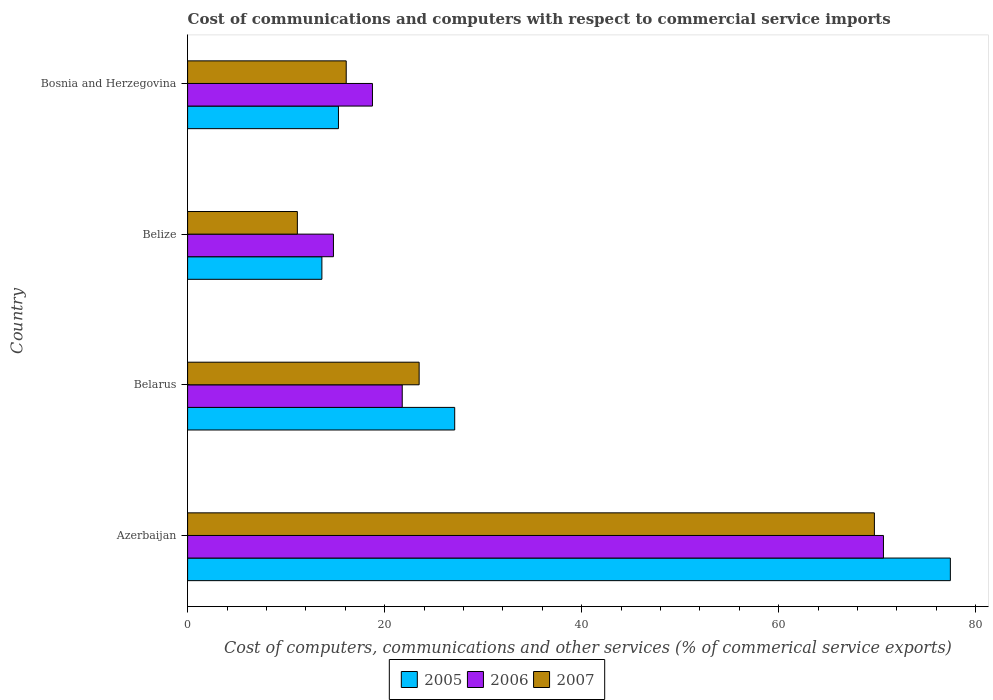How many groups of bars are there?
Provide a short and direct response. 4. Are the number of bars per tick equal to the number of legend labels?
Offer a terse response. Yes. Are the number of bars on each tick of the Y-axis equal?
Provide a short and direct response. Yes. What is the label of the 2nd group of bars from the top?
Offer a very short reply. Belize. What is the cost of communications and computers in 2007 in Belize?
Give a very brief answer. 11.14. Across all countries, what is the maximum cost of communications and computers in 2005?
Keep it short and to the point. 77.43. Across all countries, what is the minimum cost of communications and computers in 2006?
Provide a short and direct response. 14.8. In which country was the cost of communications and computers in 2005 maximum?
Your response must be concise. Azerbaijan. In which country was the cost of communications and computers in 2006 minimum?
Keep it short and to the point. Belize. What is the total cost of communications and computers in 2005 in the graph?
Keep it short and to the point. 133.49. What is the difference between the cost of communications and computers in 2007 in Azerbaijan and that in Belize?
Provide a succinct answer. 58.57. What is the difference between the cost of communications and computers in 2007 in Belize and the cost of communications and computers in 2006 in Belarus?
Your answer should be compact. -10.65. What is the average cost of communications and computers in 2006 per country?
Ensure brevity in your answer.  31.5. What is the difference between the cost of communications and computers in 2006 and cost of communications and computers in 2007 in Belarus?
Make the answer very short. -1.72. What is the ratio of the cost of communications and computers in 2006 in Azerbaijan to that in Bosnia and Herzegovina?
Your response must be concise. 3.76. What is the difference between the highest and the second highest cost of communications and computers in 2007?
Offer a very short reply. 46.21. What is the difference between the highest and the lowest cost of communications and computers in 2005?
Provide a succinct answer. 63.8. Is the sum of the cost of communications and computers in 2007 in Azerbaijan and Belize greater than the maximum cost of communications and computers in 2005 across all countries?
Your answer should be compact. Yes. What does the 1st bar from the top in Belarus represents?
Make the answer very short. 2007. How many countries are there in the graph?
Your response must be concise. 4. What is the difference between two consecutive major ticks on the X-axis?
Your answer should be compact. 20. Does the graph contain grids?
Ensure brevity in your answer.  No. What is the title of the graph?
Offer a very short reply. Cost of communications and computers with respect to commercial service imports. What is the label or title of the X-axis?
Provide a succinct answer. Cost of computers, communications and other services (% of commerical service exports). What is the Cost of computers, communications and other services (% of commerical service exports) of 2005 in Azerbaijan?
Your answer should be very brief. 77.43. What is the Cost of computers, communications and other services (% of commerical service exports) in 2006 in Azerbaijan?
Give a very brief answer. 70.64. What is the Cost of computers, communications and other services (% of commerical service exports) in 2007 in Azerbaijan?
Your answer should be very brief. 69.72. What is the Cost of computers, communications and other services (% of commerical service exports) in 2005 in Belarus?
Your answer should be very brief. 27.11. What is the Cost of computers, communications and other services (% of commerical service exports) of 2006 in Belarus?
Your response must be concise. 21.79. What is the Cost of computers, communications and other services (% of commerical service exports) of 2007 in Belarus?
Keep it short and to the point. 23.5. What is the Cost of computers, communications and other services (% of commerical service exports) in 2005 in Belize?
Provide a short and direct response. 13.63. What is the Cost of computers, communications and other services (% of commerical service exports) in 2006 in Belize?
Provide a succinct answer. 14.8. What is the Cost of computers, communications and other services (% of commerical service exports) of 2007 in Belize?
Offer a very short reply. 11.14. What is the Cost of computers, communications and other services (% of commerical service exports) in 2005 in Bosnia and Herzegovina?
Your answer should be very brief. 15.31. What is the Cost of computers, communications and other services (% of commerical service exports) in 2006 in Bosnia and Herzegovina?
Ensure brevity in your answer.  18.76. What is the Cost of computers, communications and other services (% of commerical service exports) of 2007 in Bosnia and Herzegovina?
Make the answer very short. 16.1. Across all countries, what is the maximum Cost of computers, communications and other services (% of commerical service exports) of 2005?
Provide a succinct answer. 77.43. Across all countries, what is the maximum Cost of computers, communications and other services (% of commerical service exports) in 2006?
Keep it short and to the point. 70.64. Across all countries, what is the maximum Cost of computers, communications and other services (% of commerical service exports) in 2007?
Your response must be concise. 69.72. Across all countries, what is the minimum Cost of computers, communications and other services (% of commerical service exports) of 2005?
Your response must be concise. 13.63. Across all countries, what is the minimum Cost of computers, communications and other services (% of commerical service exports) in 2006?
Give a very brief answer. 14.8. Across all countries, what is the minimum Cost of computers, communications and other services (% of commerical service exports) in 2007?
Offer a very short reply. 11.14. What is the total Cost of computers, communications and other services (% of commerical service exports) of 2005 in the graph?
Keep it short and to the point. 133.49. What is the total Cost of computers, communications and other services (% of commerical service exports) in 2006 in the graph?
Offer a terse response. 125.99. What is the total Cost of computers, communications and other services (% of commerical service exports) in 2007 in the graph?
Keep it short and to the point. 120.46. What is the difference between the Cost of computers, communications and other services (% of commerical service exports) in 2005 in Azerbaijan and that in Belarus?
Ensure brevity in your answer.  50.31. What is the difference between the Cost of computers, communications and other services (% of commerical service exports) of 2006 in Azerbaijan and that in Belarus?
Your response must be concise. 48.85. What is the difference between the Cost of computers, communications and other services (% of commerical service exports) of 2007 in Azerbaijan and that in Belarus?
Make the answer very short. 46.21. What is the difference between the Cost of computers, communications and other services (% of commerical service exports) in 2005 in Azerbaijan and that in Belize?
Offer a very short reply. 63.8. What is the difference between the Cost of computers, communications and other services (% of commerical service exports) of 2006 in Azerbaijan and that in Belize?
Offer a very short reply. 55.83. What is the difference between the Cost of computers, communications and other services (% of commerical service exports) in 2007 in Azerbaijan and that in Belize?
Offer a very short reply. 58.57. What is the difference between the Cost of computers, communications and other services (% of commerical service exports) of 2005 in Azerbaijan and that in Bosnia and Herzegovina?
Your answer should be very brief. 62.11. What is the difference between the Cost of computers, communications and other services (% of commerical service exports) of 2006 in Azerbaijan and that in Bosnia and Herzegovina?
Your response must be concise. 51.87. What is the difference between the Cost of computers, communications and other services (% of commerical service exports) in 2007 in Azerbaijan and that in Bosnia and Herzegovina?
Make the answer very short. 53.61. What is the difference between the Cost of computers, communications and other services (% of commerical service exports) of 2005 in Belarus and that in Belize?
Your response must be concise. 13.48. What is the difference between the Cost of computers, communications and other services (% of commerical service exports) in 2006 in Belarus and that in Belize?
Keep it short and to the point. 6.98. What is the difference between the Cost of computers, communications and other services (% of commerical service exports) of 2007 in Belarus and that in Belize?
Offer a terse response. 12.36. What is the difference between the Cost of computers, communications and other services (% of commerical service exports) of 2005 in Belarus and that in Bosnia and Herzegovina?
Your answer should be very brief. 11.8. What is the difference between the Cost of computers, communications and other services (% of commerical service exports) of 2006 in Belarus and that in Bosnia and Herzegovina?
Provide a short and direct response. 3.02. What is the difference between the Cost of computers, communications and other services (% of commerical service exports) of 2007 in Belarus and that in Bosnia and Herzegovina?
Ensure brevity in your answer.  7.4. What is the difference between the Cost of computers, communications and other services (% of commerical service exports) of 2005 in Belize and that in Bosnia and Herzegovina?
Your answer should be compact. -1.68. What is the difference between the Cost of computers, communications and other services (% of commerical service exports) of 2006 in Belize and that in Bosnia and Herzegovina?
Your response must be concise. -3.96. What is the difference between the Cost of computers, communications and other services (% of commerical service exports) of 2007 in Belize and that in Bosnia and Herzegovina?
Offer a very short reply. -4.96. What is the difference between the Cost of computers, communications and other services (% of commerical service exports) of 2005 in Azerbaijan and the Cost of computers, communications and other services (% of commerical service exports) of 2006 in Belarus?
Your answer should be very brief. 55.64. What is the difference between the Cost of computers, communications and other services (% of commerical service exports) of 2005 in Azerbaijan and the Cost of computers, communications and other services (% of commerical service exports) of 2007 in Belarus?
Your answer should be compact. 53.92. What is the difference between the Cost of computers, communications and other services (% of commerical service exports) of 2006 in Azerbaijan and the Cost of computers, communications and other services (% of commerical service exports) of 2007 in Belarus?
Provide a short and direct response. 47.13. What is the difference between the Cost of computers, communications and other services (% of commerical service exports) in 2005 in Azerbaijan and the Cost of computers, communications and other services (% of commerical service exports) in 2006 in Belize?
Provide a succinct answer. 62.62. What is the difference between the Cost of computers, communications and other services (% of commerical service exports) in 2005 in Azerbaijan and the Cost of computers, communications and other services (% of commerical service exports) in 2007 in Belize?
Offer a very short reply. 66.29. What is the difference between the Cost of computers, communications and other services (% of commerical service exports) of 2006 in Azerbaijan and the Cost of computers, communications and other services (% of commerical service exports) of 2007 in Belize?
Your response must be concise. 59.49. What is the difference between the Cost of computers, communications and other services (% of commerical service exports) in 2005 in Azerbaijan and the Cost of computers, communications and other services (% of commerical service exports) in 2006 in Bosnia and Herzegovina?
Make the answer very short. 58.66. What is the difference between the Cost of computers, communications and other services (% of commerical service exports) of 2005 in Azerbaijan and the Cost of computers, communications and other services (% of commerical service exports) of 2007 in Bosnia and Herzegovina?
Your response must be concise. 61.33. What is the difference between the Cost of computers, communications and other services (% of commerical service exports) of 2006 in Azerbaijan and the Cost of computers, communications and other services (% of commerical service exports) of 2007 in Bosnia and Herzegovina?
Offer a very short reply. 54.53. What is the difference between the Cost of computers, communications and other services (% of commerical service exports) in 2005 in Belarus and the Cost of computers, communications and other services (% of commerical service exports) in 2006 in Belize?
Provide a short and direct response. 12.31. What is the difference between the Cost of computers, communications and other services (% of commerical service exports) in 2005 in Belarus and the Cost of computers, communications and other services (% of commerical service exports) in 2007 in Belize?
Ensure brevity in your answer.  15.97. What is the difference between the Cost of computers, communications and other services (% of commerical service exports) in 2006 in Belarus and the Cost of computers, communications and other services (% of commerical service exports) in 2007 in Belize?
Your response must be concise. 10.65. What is the difference between the Cost of computers, communications and other services (% of commerical service exports) of 2005 in Belarus and the Cost of computers, communications and other services (% of commerical service exports) of 2006 in Bosnia and Herzegovina?
Your answer should be very brief. 8.35. What is the difference between the Cost of computers, communications and other services (% of commerical service exports) of 2005 in Belarus and the Cost of computers, communications and other services (% of commerical service exports) of 2007 in Bosnia and Herzegovina?
Provide a succinct answer. 11.01. What is the difference between the Cost of computers, communications and other services (% of commerical service exports) of 2006 in Belarus and the Cost of computers, communications and other services (% of commerical service exports) of 2007 in Bosnia and Herzegovina?
Your response must be concise. 5.69. What is the difference between the Cost of computers, communications and other services (% of commerical service exports) of 2005 in Belize and the Cost of computers, communications and other services (% of commerical service exports) of 2006 in Bosnia and Herzegovina?
Ensure brevity in your answer.  -5.13. What is the difference between the Cost of computers, communications and other services (% of commerical service exports) in 2005 in Belize and the Cost of computers, communications and other services (% of commerical service exports) in 2007 in Bosnia and Herzegovina?
Provide a succinct answer. -2.47. What is the difference between the Cost of computers, communications and other services (% of commerical service exports) in 2006 in Belize and the Cost of computers, communications and other services (% of commerical service exports) in 2007 in Bosnia and Herzegovina?
Make the answer very short. -1.3. What is the average Cost of computers, communications and other services (% of commerical service exports) of 2005 per country?
Provide a short and direct response. 33.37. What is the average Cost of computers, communications and other services (% of commerical service exports) in 2006 per country?
Your answer should be very brief. 31.5. What is the average Cost of computers, communications and other services (% of commerical service exports) in 2007 per country?
Provide a succinct answer. 30.12. What is the difference between the Cost of computers, communications and other services (% of commerical service exports) of 2005 and Cost of computers, communications and other services (% of commerical service exports) of 2006 in Azerbaijan?
Ensure brevity in your answer.  6.79. What is the difference between the Cost of computers, communications and other services (% of commerical service exports) of 2005 and Cost of computers, communications and other services (% of commerical service exports) of 2007 in Azerbaijan?
Your answer should be very brief. 7.71. What is the difference between the Cost of computers, communications and other services (% of commerical service exports) in 2006 and Cost of computers, communications and other services (% of commerical service exports) in 2007 in Azerbaijan?
Offer a very short reply. 0.92. What is the difference between the Cost of computers, communications and other services (% of commerical service exports) of 2005 and Cost of computers, communications and other services (% of commerical service exports) of 2006 in Belarus?
Keep it short and to the point. 5.33. What is the difference between the Cost of computers, communications and other services (% of commerical service exports) of 2005 and Cost of computers, communications and other services (% of commerical service exports) of 2007 in Belarus?
Provide a short and direct response. 3.61. What is the difference between the Cost of computers, communications and other services (% of commerical service exports) in 2006 and Cost of computers, communications and other services (% of commerical service exports) in 2007 in Belarus?
Provide a succinct answer. -1.72. What is the difference between the Cost of computers, communications and other services (% of commerical service exports) of 2005 and Cost of computers, communications and other services (% of commerical service exports) of 2006 in Belize?
Give a very brief answer. -1.17. What is the difference between the Cost of computers, communications and other services (% of commerical service exports) of 2005 and Cost of computers, communications and other services (% of commerical service exports) of 2007 in Belize?
Your answer should be compact. 2.49. What is the difference between the Cost of computers, communications and other services (% of commerical service exports) in 2006 and Cost of computers, communications and other services (% of commerical service exports) in 2007 in Belize?
Provide a short and direct response. 3.66. What is the difference between the Cost of computers, communications and other services (% of commerical service exports) in 2005 and Cost of computers, communications and other services (% of commerical service exports) in 2006 in Bosnia and Herzegovina?
Your answer should be very brief. -3.45. What is the difference between the Cost of computers, communications and other services (% of commerical service exports) of 2005 and Cost of computers, communications and other services (% of commerical service exports) of 2007 in Bosnia and Herzegovina?
Make the answer very short. -0.79. What is the difference between the Cost of computers, communications and other services (% of commerical service exports) in 2006 and Cost of computers, communications and other services (% of commerical service exports) in 2007 in Bosnia and Herzegovina?
Offer a terse response. 2.66. What is the ratio of the Cost of computers, communications and other services (% of commerical service exports) in 2005 in Azerbaijan to that in Belarus?
Provide a short and direct response. 2.86. What is the ratio of the Cost of computers, communications and other services (% of commerical service exports) in 2006 in Azerbaijan to that in Belarus?
Your response must be concise. 3.24. What is the ratio of the Cost of computers, communications and other services (% of commerical service exports) in 2007 in Azerbaijan to that in Belarus?
Provide a succinct answer. 2.97. What is the ratio of the Cost of computers, communications and other services (% of commerical service exports) of 2005 in Azerbaijan to that in Belize?
Provide a short and direct response. 5.68. What is the ratio of the Cost of computers, communications and other services (% of commerical service exports) in 2006 in Azerbaijan to that in Belize?
Your answer should be very brief. 4.77. What is the ratio of the Cost of computers, communications and other services (% of commerical service exports) in 2007 in Azerbaijan to that in Belize?
Offer a terse response. 6.26. What is the ratio of the Cost of computers, communications and other services (% of commerical service exports) in 2005 in Azerbaijan to that in Bosnia and Herzegovina?
Provide a short and direct response. 5.06. What is the ratio of the Cost of computers, communications and other services (% of commerical service exports) in 2006 in Azerbaijan to that in Bosnia and Herzegovina?
Your answer should be very brief. 3.76. What is the ratio of the Cost of computers, communications and other services (% of commerical service exports) in 2007 in Azerbaijan to that in Bosnia and Herzegovina?
Your response must be concise. 4.33. What is the ratio of the Cost of computers, communications and other services (% of commerical service exports) in 2005 in Belarus to that in Belize?
Provide a succinct answer. 1.99. What is the ratio of the Cost of computers, communications and other services (% of commerical service exports) of 2006 in Belarus to that in Belize?
Give a very brief answer. 1.47. What is the ratio of the Cost of computers, communications and other services (% of commerical service exports) of 2007 in Belarus to that in Belize?
Offer a terse response. 2.11. What is the ratio of the Cost of computers, communications and other services (% of commerical service exports) in 2005 in Belarus to that in Bosnia and Herzegovina?
Your answer should be very brief. 1.77. What is the ratio of the Cost of computers, communications and other services (% of commerical service exports) in 2006 in Belarus to that in Bosnia and Herzegovina?
Make the answer very short. 1.16. What is the ratio of the Cost of computers, communications and other services (% of commerical service exports) of 2007 in Belarus to that in Bosnia and Herzegovina?
Your response must be concise. 1.46. What is the ratio of the Cost of computers, communications and other services (% of commerical service exports) in 2005 in Belize to that in Bosnia and Herzegovina?
Ensure brevity in your answer.  0.89. What is the ratio of the Cost of computers, communications and other services (% of commerical service exports) of 2006 in Belize to that in Bosnia and Herzegovina?
Provide a short and direct response. 0.79. What is the ratio of the Cost of computers, communications and other services (% of commerical service exports) in 2007 in Belize to that in Bosnia and Herzegovina?
Your answer should be compact. 0.69. What is the difference between the highest and the second highest Cost of computers, communications and other services (% of commerical service exports) in 2005?
Provide a succinct answer. 50.31. What is the difference between the highest and the second highest Cost of computers, communications and other services (% of commerical service exports) of 2006?
Your response must be concise. 48.85. What is the difference between the highest and the second highest Cost of computers, communications and other services (% of commerical service exports) in 2007?
Provide a succinct answer. 46.21. What is the difference between the highest and the lowest Cost of computers, communications and other services (% of commerical service exports) of 2005?
Your answer should be very brief. 63.8. What is the difference between the highest and the lowest Cost of computers, communications and other services (% of commerical service exports) in 2006?
Provide a succinct answer. 55.83. What is the difference between the highest and the lowest Cost of computers, communications and other services (% of commerical service exports) in 2007?
Provide a succinct answer. 58.57. 